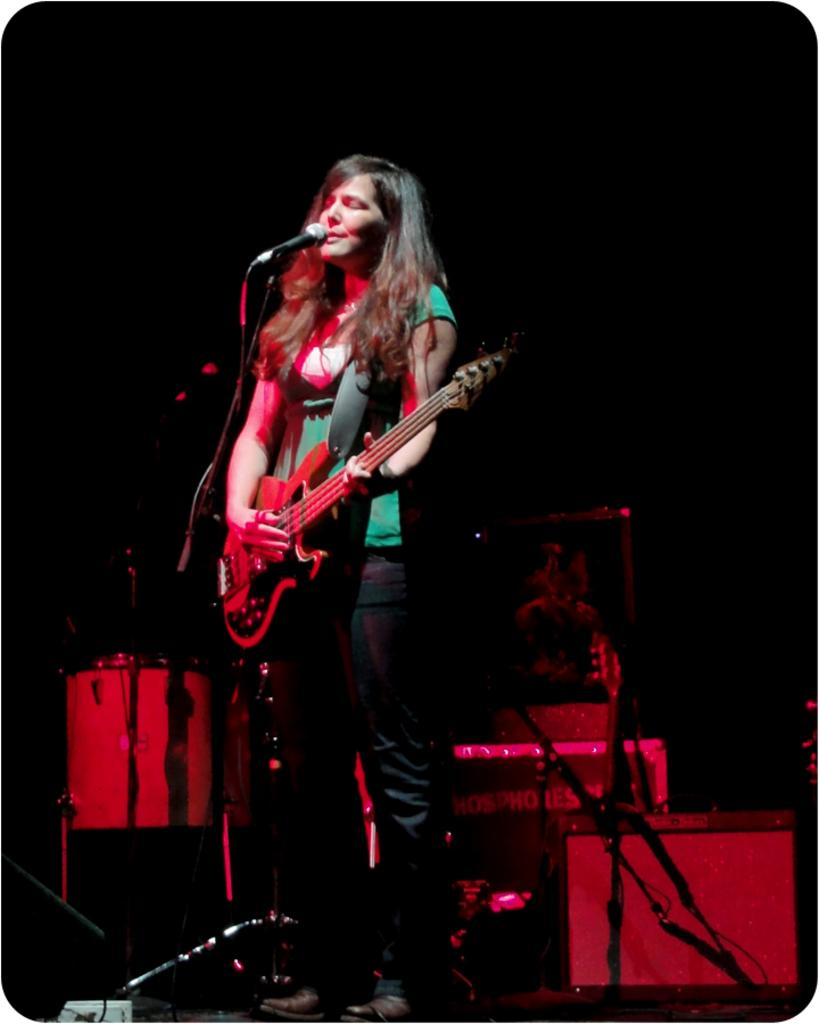Who is the main subject in the image? There is a lady in the image. What is the lady holding in the image? The lady is holding a guitar. What is the lady doing with the guitar? The lady is playing the guitar. How is the lady's voice being amplified in the image? The lady is singing through a microphone. What other musical instruments can be seen in the background of the image? There are electronic drums in the background of the image. What type of sweater is the lady wearing in the image? The provided facts do not mention any clothing, including a sweater, so we cannot determine what type of sweater the lady is wearing in the image. 